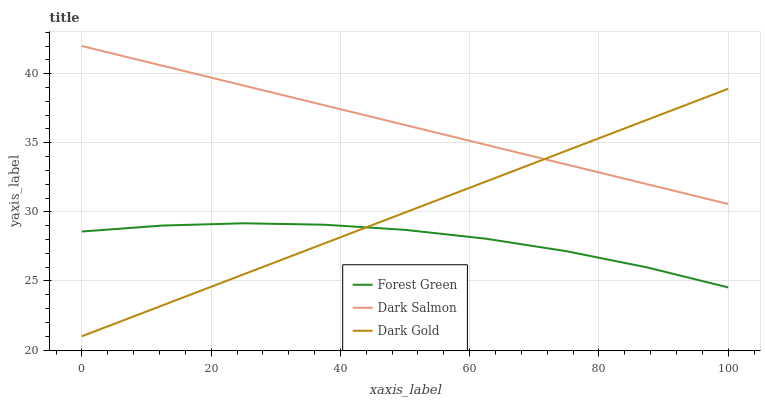Does Dark Gold have the minimum area under the curve?
Answer yes or no. No. Does Dark Gold have the maximum area under the curve?
Answer yes or no. No. Is Dark Salmon the smoothest?
Answer yes or no. No. Is Dark Salmon the roughest?
Answer yes or no. No. Does Dark Salmon have the lowest value?
Answer yes or no. No. Does Dark Gold have the highest value?
Answer yes or no. No. Is Forest Green less than Dark Salmon?
Answer yes or no. Yes. Is Dark Salmon greater than Forest Green?
Answer yes or no. Yes. Does Forest Green intersect Dark Salmon?
Answer yes or no. No. 